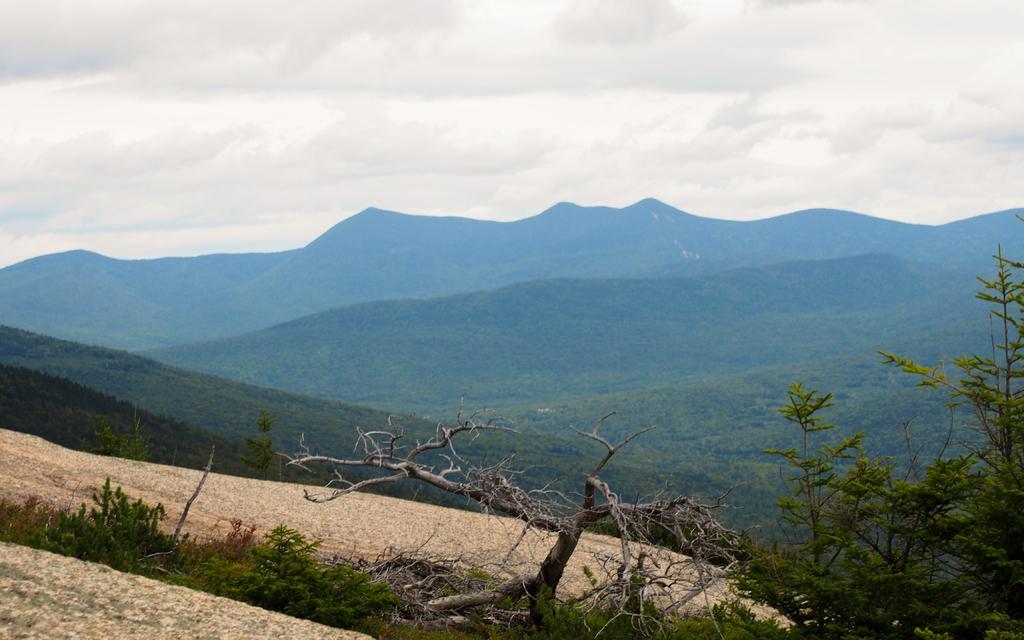Can you describe this image briefly? In this image there are mountains and trees. 